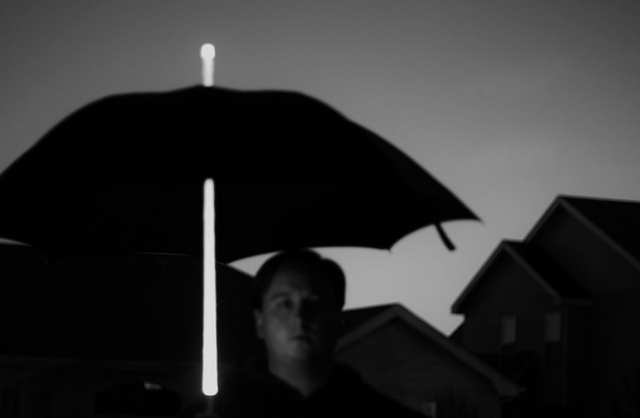<image>What is the weather like? I don't know what the weather is like. It could be clear, rainy, cloudy, gloomy, or overcast. What is the weather like? I don't know what the weather is like. It can be either clear, rainy, cloudy, or gloomy. 